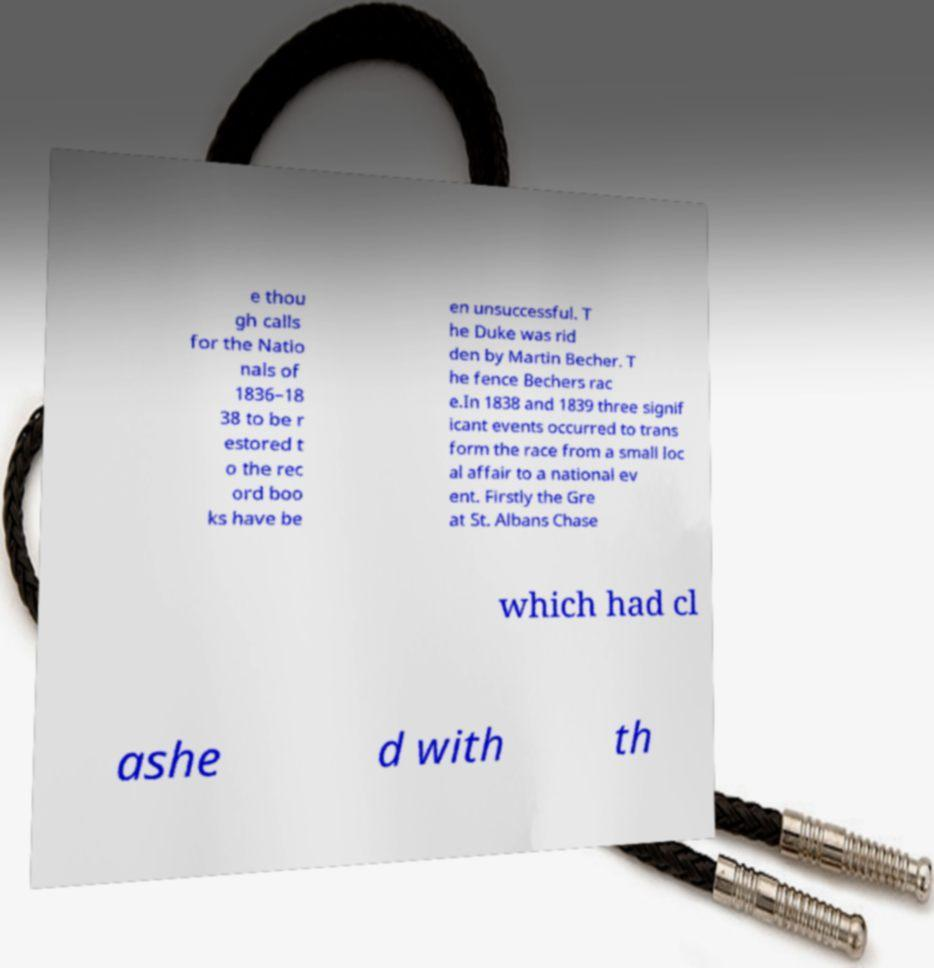Please identify and transcribe the text found in this image. e thou gh calls for the Natio nals of 1836–18 38 to be r estored t o the rec ord boo ks have be en unsuccessful. T he Duke was rid den by Martin Becher. T he fence Bechers rac e.In 1838 and 1839 three signif icant events occurred to trans form the race from a small loc al affair to a national ev ent. Firstly the Gre at St. Albans Chase which had cl ashe d with th 